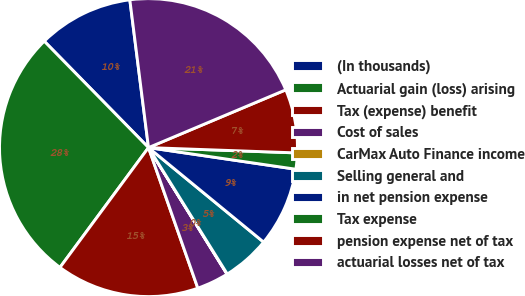Convert chart to OTSL. <chart><loc_0><loc_0><loc_500><loc_500><pie_chart><fcel>(In thousands)<fcel>Actuarial gain (loss) arising<fcel>Tax (expense) benefit<fcel>Cost of sales<fcel>CarMax Auto Finance income<fcel>Selling general and<fcel>in net pension expense<fcel>Tax expense<fcel>pension expense net of tax<fcel>actuarial losses net of tax<nl><fcel>10.34%<fcel>27.54%<fcel>15.5%<fcel>3.47%<fcel>0.03%<fcel>5.19%<fcel>8.62%<fcel>1.75%<fcel>6.91%<fcel>20.66%<nl></chart> 